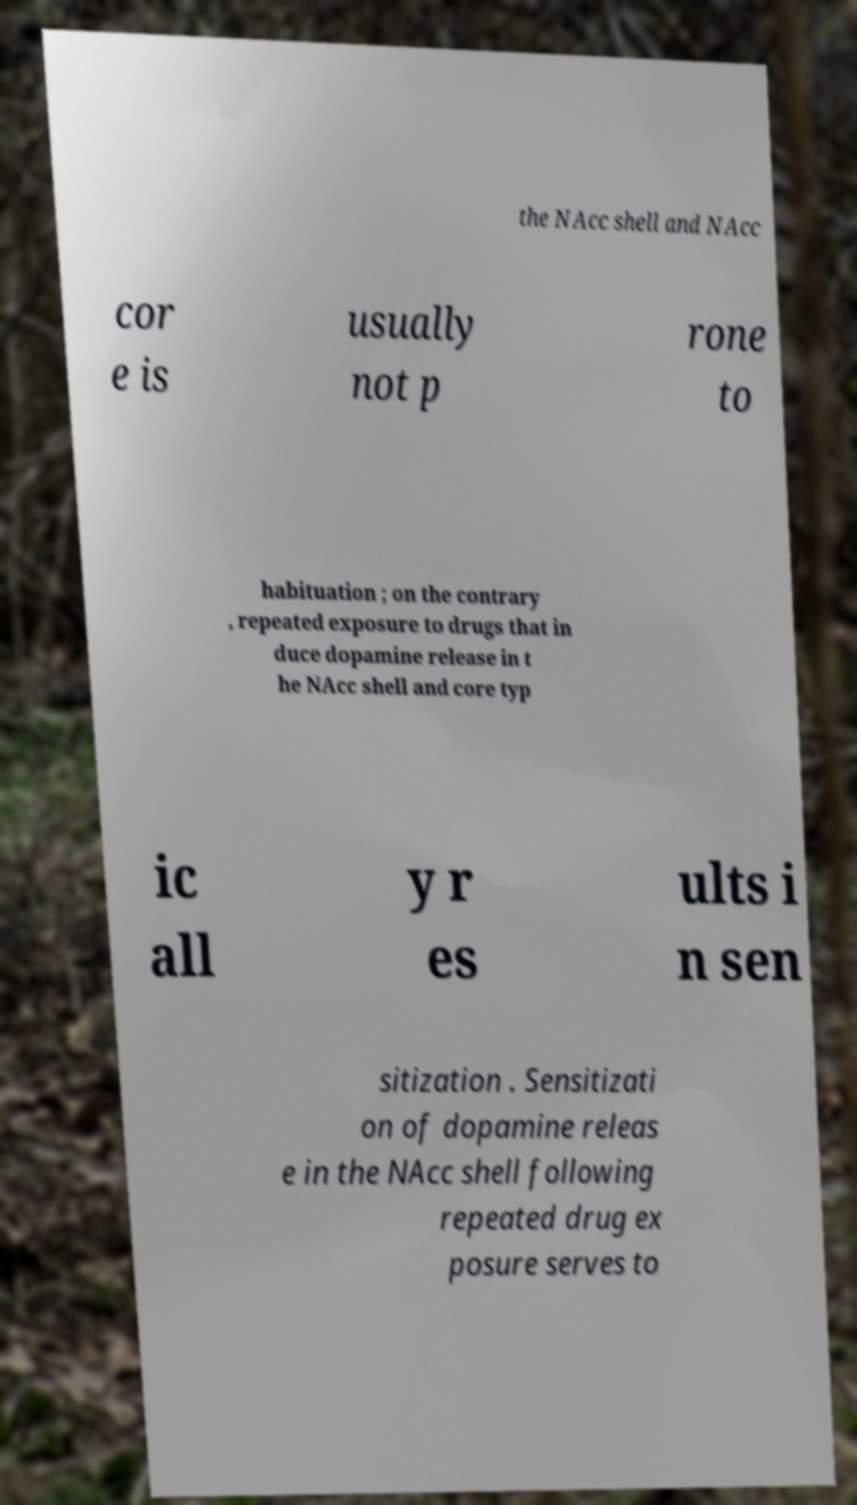Could you extract and type out the text from this image? the NAcc shell and NAcc cor e is usually not p rone to habituation ; on the contrary , repeated exposure to drugs that in duce dopamine release in t he NAcc shell and core typ ic all y r es ults i n sen sitization . Sensitizati on of dopamine releas e in the NAcc shell following repeated drug ex posure serves to 